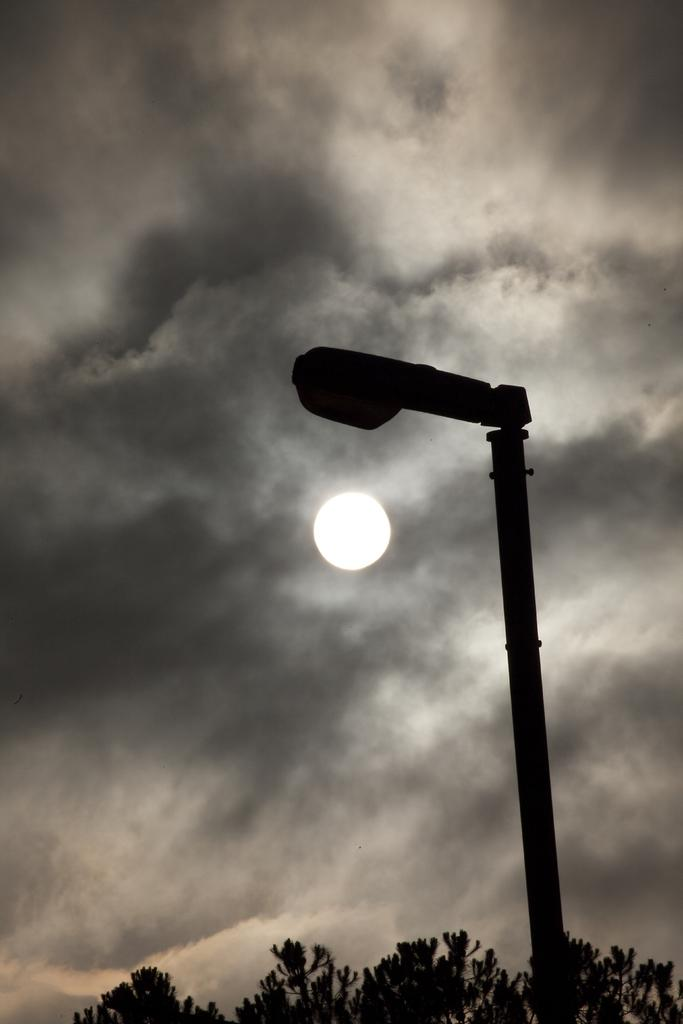What is located in the foreground of the image? There is a lamp pole and a tree in the foreground of the image. Can you describe the background of the image? There is a moon visible in the sky in the background of the image. What type of blood is visible on the instrument in the image? There is no instrument or blood present in the image. 